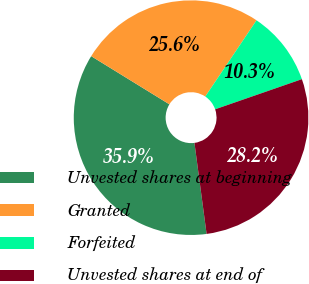Convert chart to OTSL. <chart><loc_0><loc_0><loc_500><loc_500><pie_chart><fcel>Unvested shares at beginning<fcel>Granted<fcel>Forfeited<fcel>Unvested shares at end of<nl><fcel>35.9%<fcel>25.64%<fcel>10.26%<fcel>28.21%<nl></chart> 